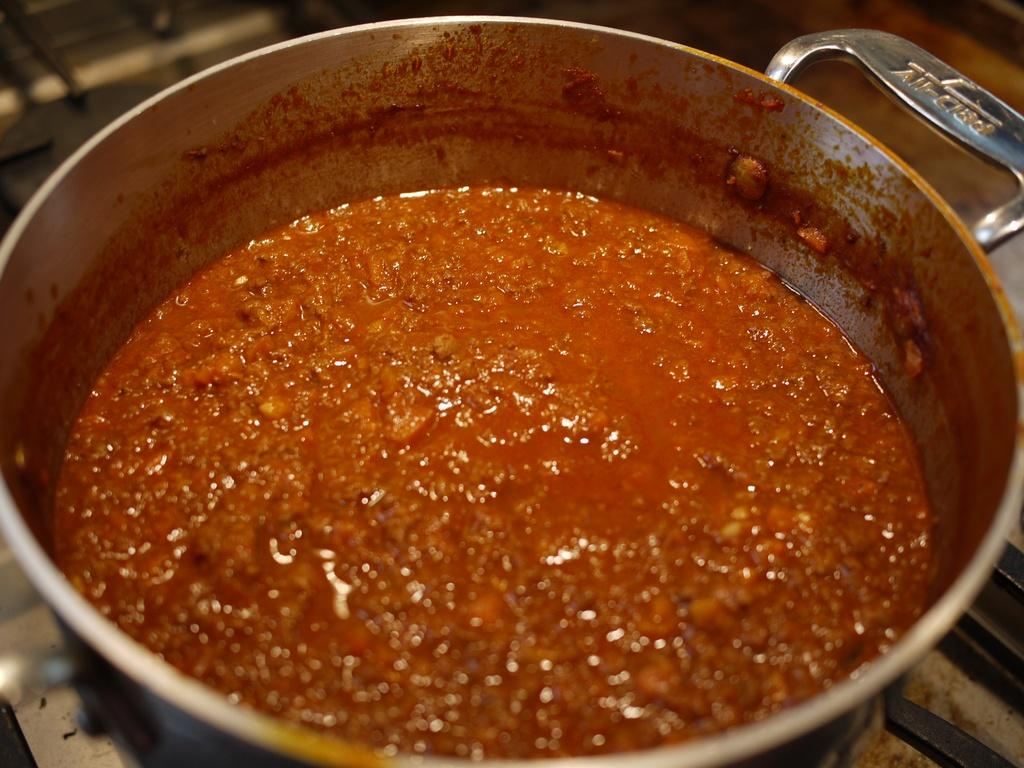What object in the image is used for holding or storing items? There is a container in the image. What is inside the container in the image? There is food in the container. Can you describe the background of the image? The background of the image is blurred. How many cherries can be seen on the chairs in the image? There are no cherries or chairs present in the image. What type of bird can be seen flying in the image? There is no bird present in the image. 